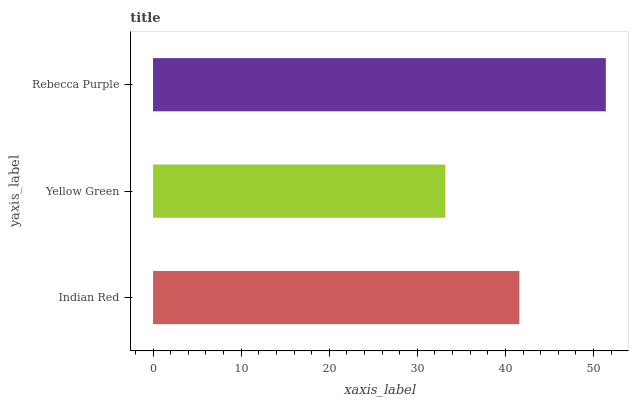Is Yellow Green the minimum?
Answer yes or no. Yes. Is Rebecca Purple the maximum?
Answer yes or no. Yes. Is Rebecca Purple the minimum?
Answer yes or no. No. Is Yellow Green the maximum?
Answer yes or no. No. Is Rebecca Purple greater than Yellow Green?
Answer yes or no. Yes. Is Yellow Green less than Rebecca Purple?
Answer yes or no. Yes. Is Yellow Green greater than Rebecca Purple?
Answer yes or no. No. Is Rebecca Purple less than Yellow Green?
Answer yes or no. No. Is Indian Red the high median?
Answer yes or no. Yes. Is Indian Red the low median?
Answer yes or no. Yes. Is Rebecca Purple the high median?
Answer yes or no. No. Is Yellow Green the low median?
Answer yes or no. No. 